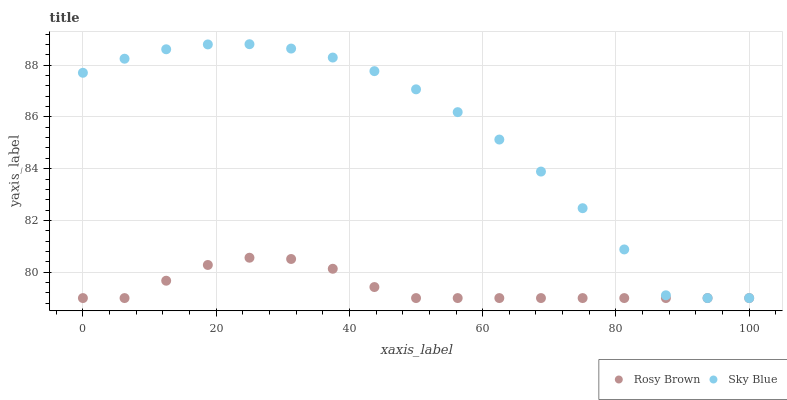Does Rosy Brown have the minimum area under the curve?
Answer yes or no. Yes. Does Sky Blue have the maximum area under the curve?
Answer yes or no. Yes. Does Rosy Brown have the maximum area under the curve?
Answer yes or no. No. Is Rosy Brown the smoothest?
Answer yes or no. Yes. Is Sky Blue the roughest?
Answer yes or no. Yes. Is Rosy Brown the roughest?
Answer yes or no. No. Does Sky Blue have the lowest value?
Answer yes or no. Yes. Does Sky Blue have the highest value?
Answer yes or no. Yes. Does Rosy Brown have the highest value?
Answer yes or no. No. Does Sky Blue intersect Rosy Brown?
Answer yes or no. Yes. Is Sky Blue less than Rosy Brown?
Answer yes or no. No. Is Sky Blue greater than Rosy Brown?
Answer yes or no. No. 